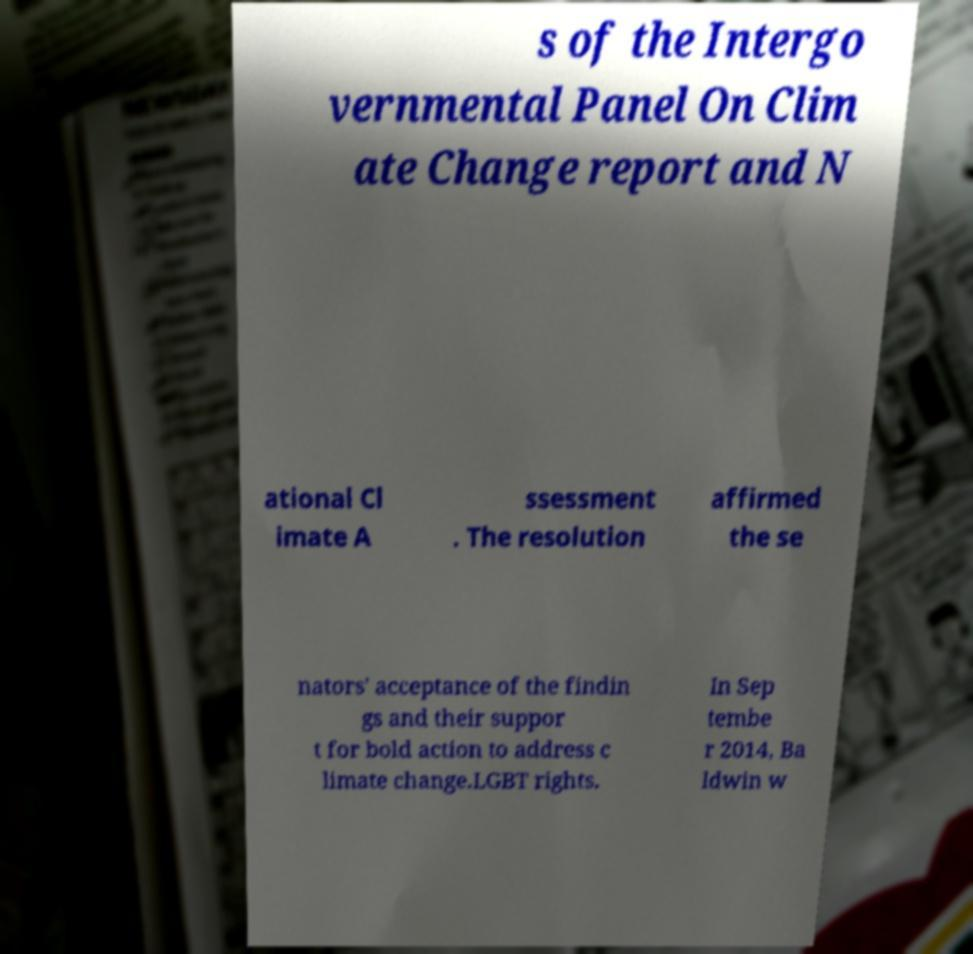Please read and relay the text visible in this image. What does it say? s of the Intergo vernmental Panel On Clim ate Change report and N ational Cl imate A ssessment . The resolution affirmed the se nators' acceptance of the findin gs and their suppor t for bold action to address c limate change.LGBT rights. In Sep tembe r 2014, Ba ldwin w 